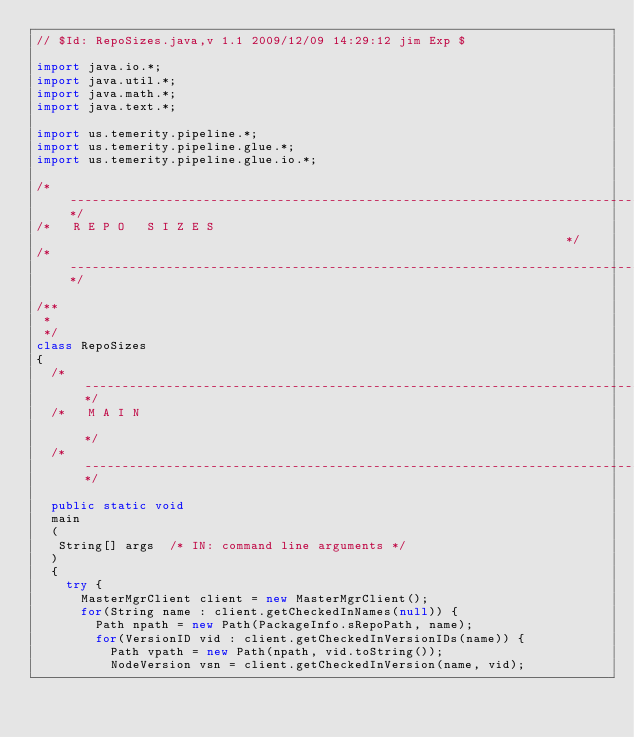Convert code to text. <code><loc_0><loc_0><loc_500><loc_500><_Java_>// $Id: RepoSizes.java,v 1.1 2009/12/09 14:29:12 jim Exp $

import java.io.*; 
import java.util.*; 
import java.math.*; 
import java.text.*;

import us.temerity.pipeline.*;
import us.temerity.pipeline.glue.*;
import us.temerity.pipeline.glue.io.*;

/*------------------------------------------------------------------------------------------*/
/*   R E P O   S I Z E S                                                                    */
/*------------------------------------------------------------------------------------------*/

/**
 * 
 */ 
class RepoSizes
{  
  /*----------------------------------------------------------------------------------------*/
  /*   M A I N                                                                              */
  /*----------------------------------------------------------------------------------------*/

  public static void 
  main
  (
   String[] args  /* IN: command line arguments */
  )
  {
    try {
      MasterMgrClient client = new MasterMgrClient();
      for(String name : client.getCheckedInNames(null)) {
        Path npath = new Path(PackageInfo.sRepoPath, name);
        for(VersionID vid : client.getCheckedInVersionIDs(name)) {
          Path vpath = new Path(npath, vid.toString());
          NodeVersion vsn = client.getCheckedInVersion(name, vid);</code> 